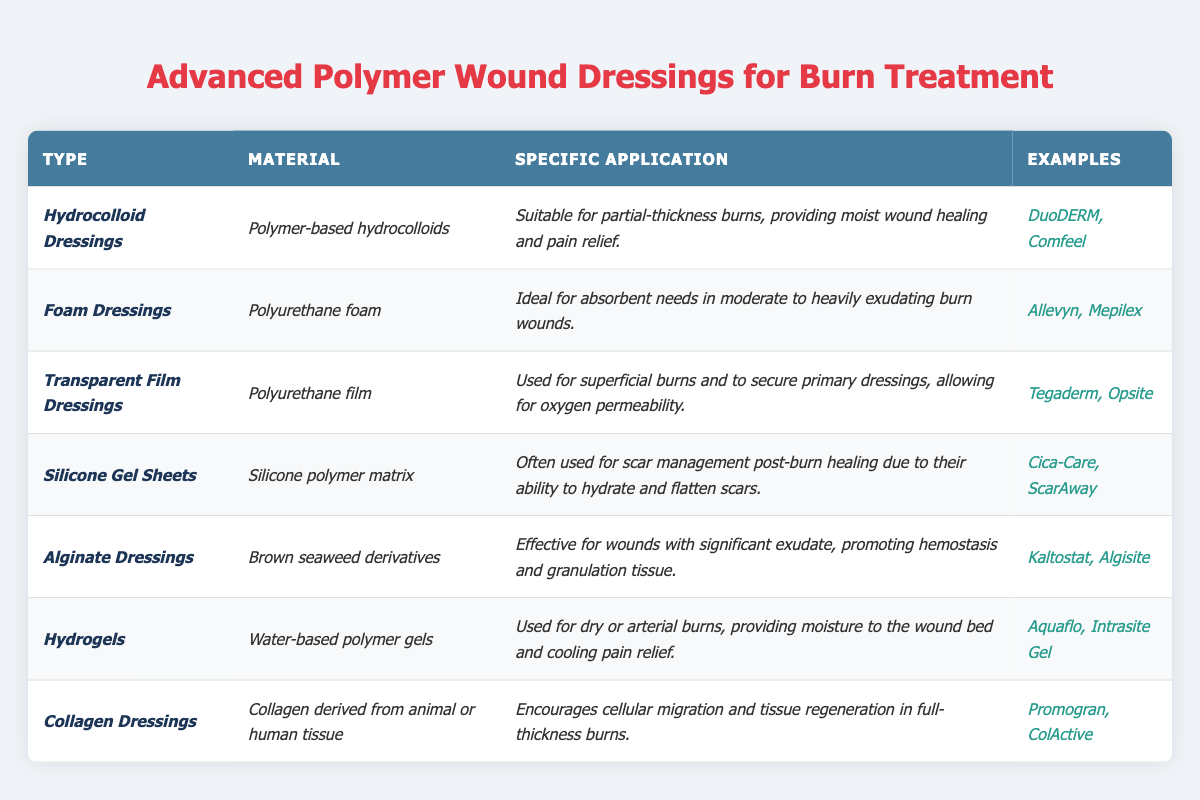What type of polymer dressing is ideal for managing moderate to heavily exudating burn wounds? By reviewing the table, it is clear that "Foam Dressings" are marked as ideal for absorbent needs in moderate to heavily exudating burn wounds.
Answer: Foam Dressings Which dressing type is specifically suitable for partial-thickness burns? The table indicates that "Hydrocolloid Dressings" are suitable for partial-thickness burns, focusing on moist wound healing and pain relief.
Answer: Hydrocolloid Dressings Is "Cica-Care" an example of a Hydrocolloid Dressing? The table states that "Cica-Care" is listed under "Silicone Gel Sheets," meaning it is not an example of a Hydrocolloid Dressing.
Answer: No How many dressing types listed are specifically effective for wounds with significant exudate? The table mentions "Foam Dressings" and "Alginate Dressings" as suitable for moderate to heavily exudating burn wounds; therefore, there are 2 types.
Answer: 2 What material is used in Transparent Film Dressings? The table specifies that the material used in Transparent Film Dressings is "Polyurethane film."
Answer: Polyurethane film Which type of dressing is used for scar management post-burn healing? According to the table, "Silicone Gel Sheets" are cited as the type used for scar management post-burn healing, as they hydrate and flatten scars.
Answer: Silicone Gel Sheets What is the primary function of Alginate Dressings? The primary function of Alginate Dressings is to be effective for wounds with significant exudate, promoting hemostasis and granulation tissue, as described in the table.
Answer: Promote hemostasis and granulation tissue Which two dressing types utilize a polymer-based material? From the table, "Hydrocolloid Dressings" use "Polymer-based hydrocolloids," and "Foam Dressings" use "Polyurethane foam," so both types utilize polymer-based materials.
Answer: Hydrocolloid and Foam Dressings What dressing type provides cooling pain relief for dry or arterial burns? "Hydrogels" are identified in the table as providing moisture to the wound bed and cooling pain relief specifically for dry or arterial burns.
Answer: Hydrogels Count the number of dressing types that allow for oxygen permeability. The table notes that "Transparent Film Dressings" allow for oxygen permeability, indicating that only 1 type serves this function.
Answer: 1 Are there any dressings listed that come from natural sources? The table confirms that "Collagen Dressings," derived from animal or human tissue, and "Alginate Dressings," sourced from brown seaweed, are examples of dressings from natural sources.
Answer: Yes 